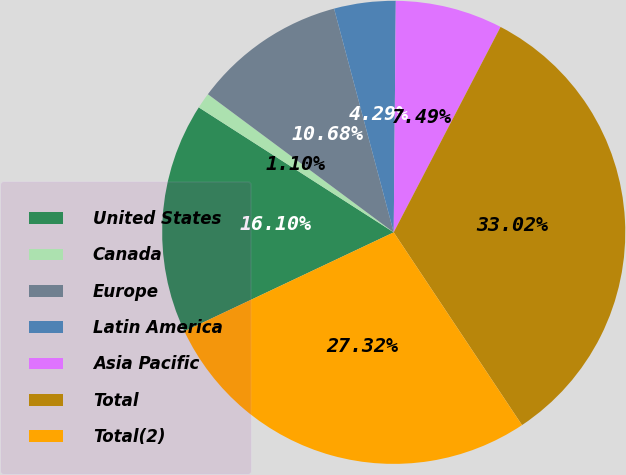Convert chart to OTSL. <chart><loc_0><loc_0><loc_500><loc_500><pie_chart><fcel>United States<fcel>Canada<fcel>Europe<fcel>Latin America<fcel>Asia Pacific<fcel>Total<fcel>Total(2)<nl><fcel>16.1%<fcel>1.1%<fcel>10.68%<fcel>4.29%<fcel>7.49%<fcel>33.02%<fcel>27.32%<nl></chart> 